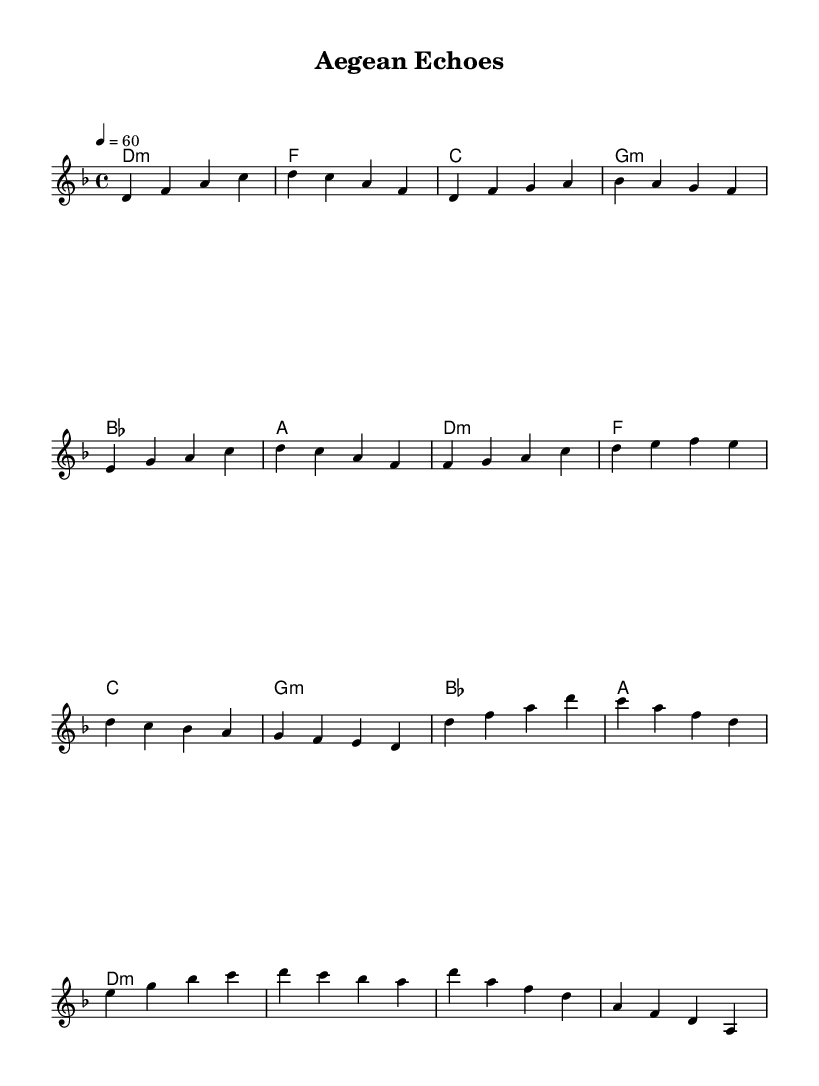What is the key signature of this music? The key signature is indicated at the beginning of the score, and in this case, it is D minor which has one flat (B flat).
Answer: D minor What is the time signature of the piece? The time signature is found at the beginning of the music, shown as 4/4, which indicates four beats per measure and a quarter note gets one beat.
Answer: 4/4 What is the tempo marking given in the score? The tempo marking is shown in beats per minute, specifically noted as 4 = 60, which indicates that the quarter note should be played at a tempo of 60 beats per minute.
Answer: 60 What is the overall mood conveyed by the chord progression in the harmony section? Analyzing the chord progression, it alternates between minor and major chords, primarily centered around D minor, suggesting a somewhat contemplative and serene ambiance, typical of ambient electronic music.
Answer: Contemplative Which instrumental voice is primarily featured in the melody? In the score, the notation indicates that the Melody is written for a solo instrument, recognized here as "melody."
Answer: Melody What is the final chord in the piece? The last chord is indicated in the harmony section and is noted as D minor, which gives a sense of resolution to the piece.
Answer: D minor 